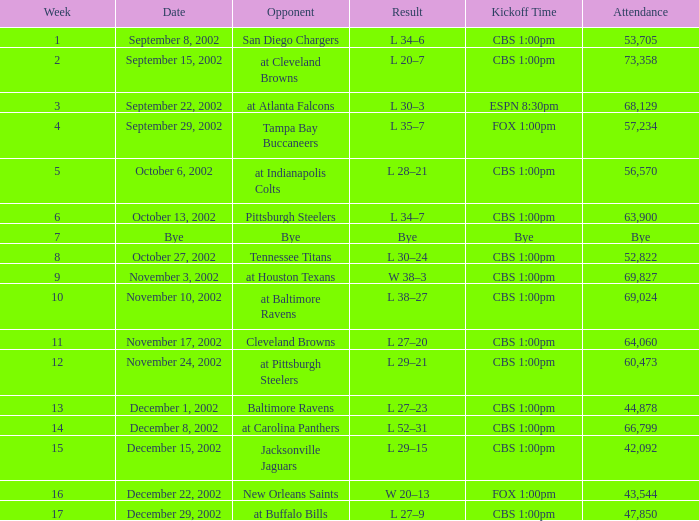What is the kickoff time on November 10, 2002? CBS 1:00pm. 